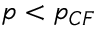<formula> <loc_0><loc_0><loc_500><loc_500>p < p _ { C F }</formula> 